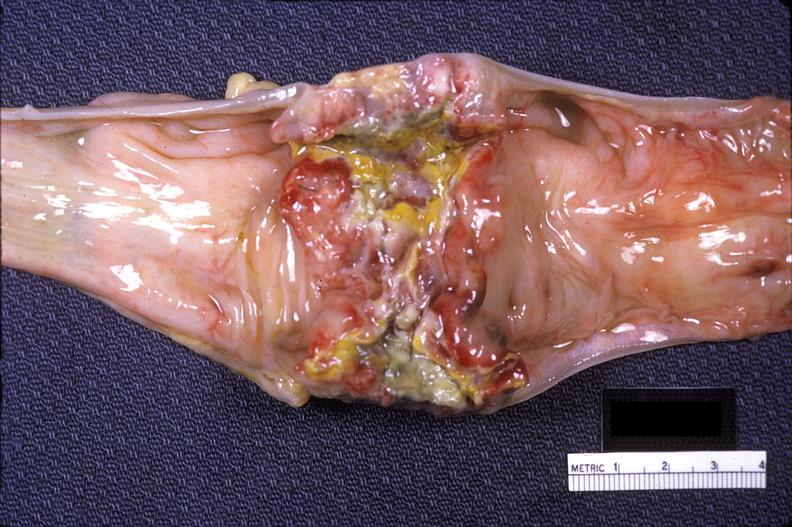what is present?
Answer the question using a single word or phrase. Gastrointestinal 